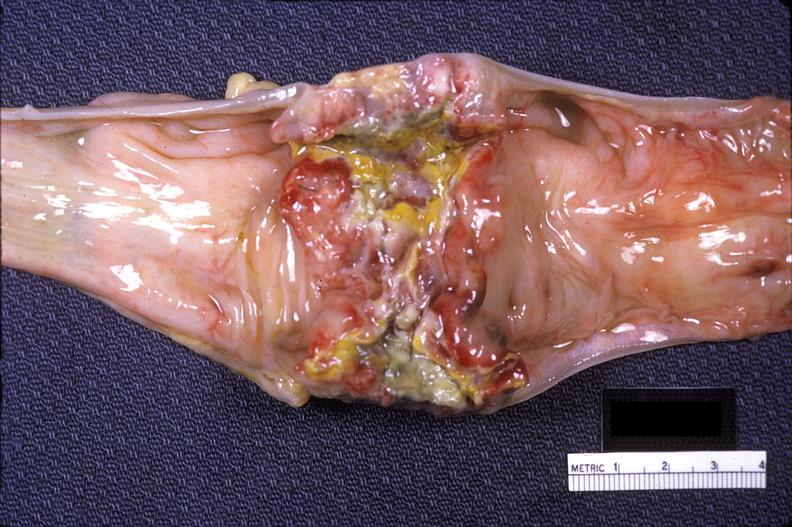what is present?
Answer the question using a single word or phrase. Gastrointestinal 